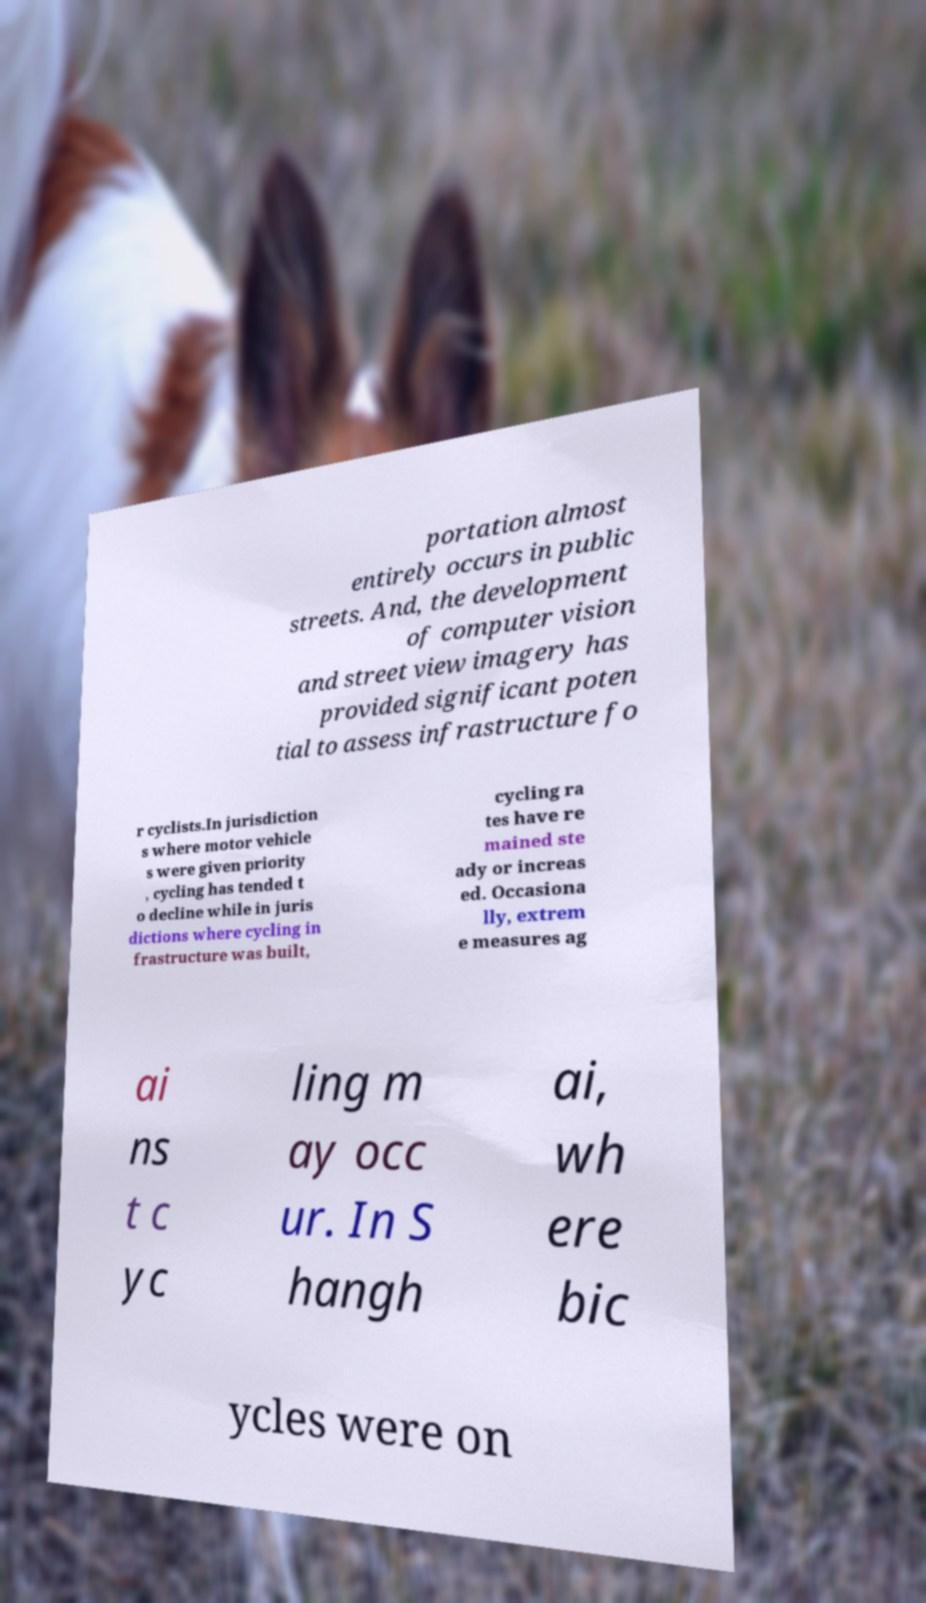Could you extract and type out the text from this image? portation almost entirely occurs in public streets. And, the development of computer vision and street view imagery has provided significant poten tial to assess infrastructure fo r cyclists.In jurisdiction s where motor vehicle s were given priority , cycling has tended t o decline while in juris dictions where cycling in frastructure was built, cycling ra tes have re mained ste ady or increas ed. Occasiona lly, extrem e measures ag ai ns t c yc ling m ay occ ur. In S hangh ai, wh ere bic ycles were on 